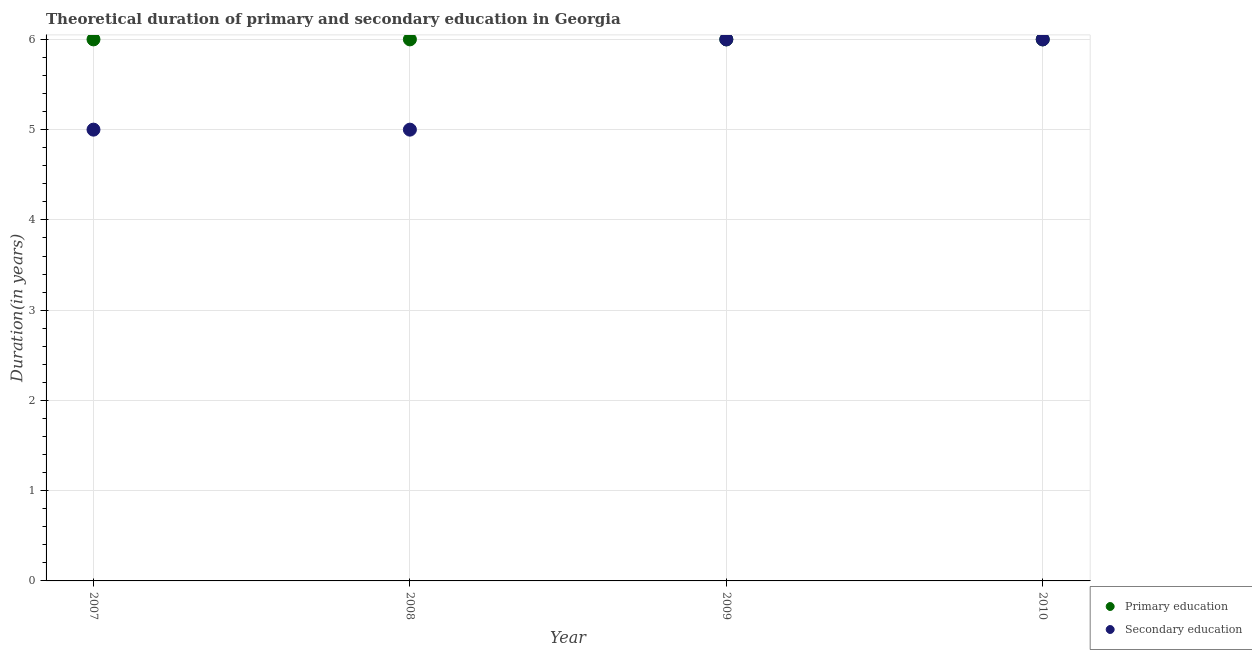How many different coloured dotlines are there?
Provide a short and direct response. 2. Is the number of dotlines equal to the number of legend labels?
Ensure brevity in your answer.  Yes. Across all years, what is the minimum duration of secondary education?
Offer a terse response. 5. In which year was the duration of secondary education maximum?
Provide a succinct answer. 2009. In which year was the duration of primary education minimum?
Ensure brevity in your answer.  2007. What is the total duration of primary education in the graph?
Provide a succinct answer. 24. What is the difference between the duration of secondary education in 2008 and that in 2010?
Ensure brevity in your answer.  -1. What is the difference between the duration of secondary education in 2007 and the duration of primary education in 2008?
Give a very brief answer. -1. What is the ratio of the duration of primary education in 2007 to that in 2009?
Ensure brevity in your answer.  1. What is the difference between the highest and the lowest duration of primary education?
Offer a terse response. 0. Does the duration of secondary education monotonically increase over the years?
Keep it short and to the point. No. Is the duration of primary education strictly greater than the duration of secondary education over the years?
Provide a short and direct response. No. Is the duration of secondary education strictly less than the duration of primary education over the years?
Your answer should be very brief. No. How many dotlines are there?
Offer a terse response. 2. What is the difference between two consecutive major ticks on the Y-axis?
Ensure brevity in your answer.  1. Are the values on the major ticks of Y-axis written in scientific E-notation?
Your response must be concise. No. Does the graph contain grids?
Your answer should be compact. Yes. Where does the legend appear in the graph?
Offer a terse response. Bottom right. How are the legend labels stacked?
Keep it short and to the point. Vertical. What is the title of the graph?
Give a very brief answer. Theoretical duration of primary and secondary education in Georgia. Does "Lowest 10% of population" appear as one of the legend labels in the graph?
Keep it short and to the point. No. What is the label or title of the X-axis?
Provide a succinct answer. Year. What is the label or title of the Y-axis?
Provide a short and direct response. Duration(in years). What is the Duration(in years) in Secondary education in 2007?
Make the answer very short. 5. What is the Duration(in years) of Secondary education in 2009?
Keep it short and to the point. 6. What is the Duration(in years) of Primary education in 2010?
Offer a terse response. 6. What is the Duration(in years) in Secondary education in 2010?
Make the answer very short. 6. Across all years, what is the maximum Duration(in years) in Primary education?
Ensure brevity in your answer.  6. Across all years, what is the maximum Duration(in years) in Secondary education?
Keep it short and to the point. 6. Across all years, what is the minimum Duration(in years) in Secondary education?
Make the answer very short. 5. What is the total Duration(in years) of Primary education in the graph?
Make the answer very short. 24. What is the difference between the Duration(in years) in Primary education in 2007 and that in 2008?
Make the answer very short. 0. What is the difference between the Duration(in years) in Secondary education in 2007 and that in 2008?
Ensure brevity in your answer.  0. What is the difference between the Duration(in years) in Primary education in 2008 and that in 2009?
Provide a succinct answer. 0. What is the difference between the Duration(in years) in Primary education in 2008 and that in 2010?
Your answer should be compact. 0. What is the difference between the Duration(in years) in Secondary education in 2009 and that in 2010?
Your response must be concise. 0. What is the difference between the Duration(in years) in Primary education in 2007 and the Duration(in years) in Secondary education in 2008?
Your answer should be very brief. 1. What is the difference between the Duration(in years) of Primary education in 2008 and the Duration(in years) of Secondary education in 2009?
Provide a short and direct response. 0. What is the difference between the Duration(in years) of Primary education in 2009 and the Duration(in years) of Secondary education in 2010?
Offer a terse response. 0. In the year 2008, what is the difference between the Duration(in years) of Primary education and Duration(in years) of Secondary education?
Provide a short and direct response. 1. In the year 2009, what is the difference between the Duration(in years) in Primary education and Duration(in years) in Secondary education?
Keep it short and to the point. 0. What is the ratio of the Duration(in years) of Primary education in 2007 to that in 2009?
Provide a succinct answer. 1. What is the ratio of the Duration(in years) in Primary education in 2007 to that in 2010?
Keep it short and to the point. 1. What is the ratio of the Duration(in years) in Secondary education in 2008 to that in 2009?
Offer a very short reply. 0.83. What is the ratio of the Duration(in years) in Primary education in 2009 to that in 2010?
Keep it short and to the point. 1. What is the ratio of the Duration(in years) in Secondary education in 2009 to that in 2010?
Provide a short and direct response. 1. What is the difference between the highest and the lowest Duration(in years) of Primary education?
Provide a succinct answer. 0. 